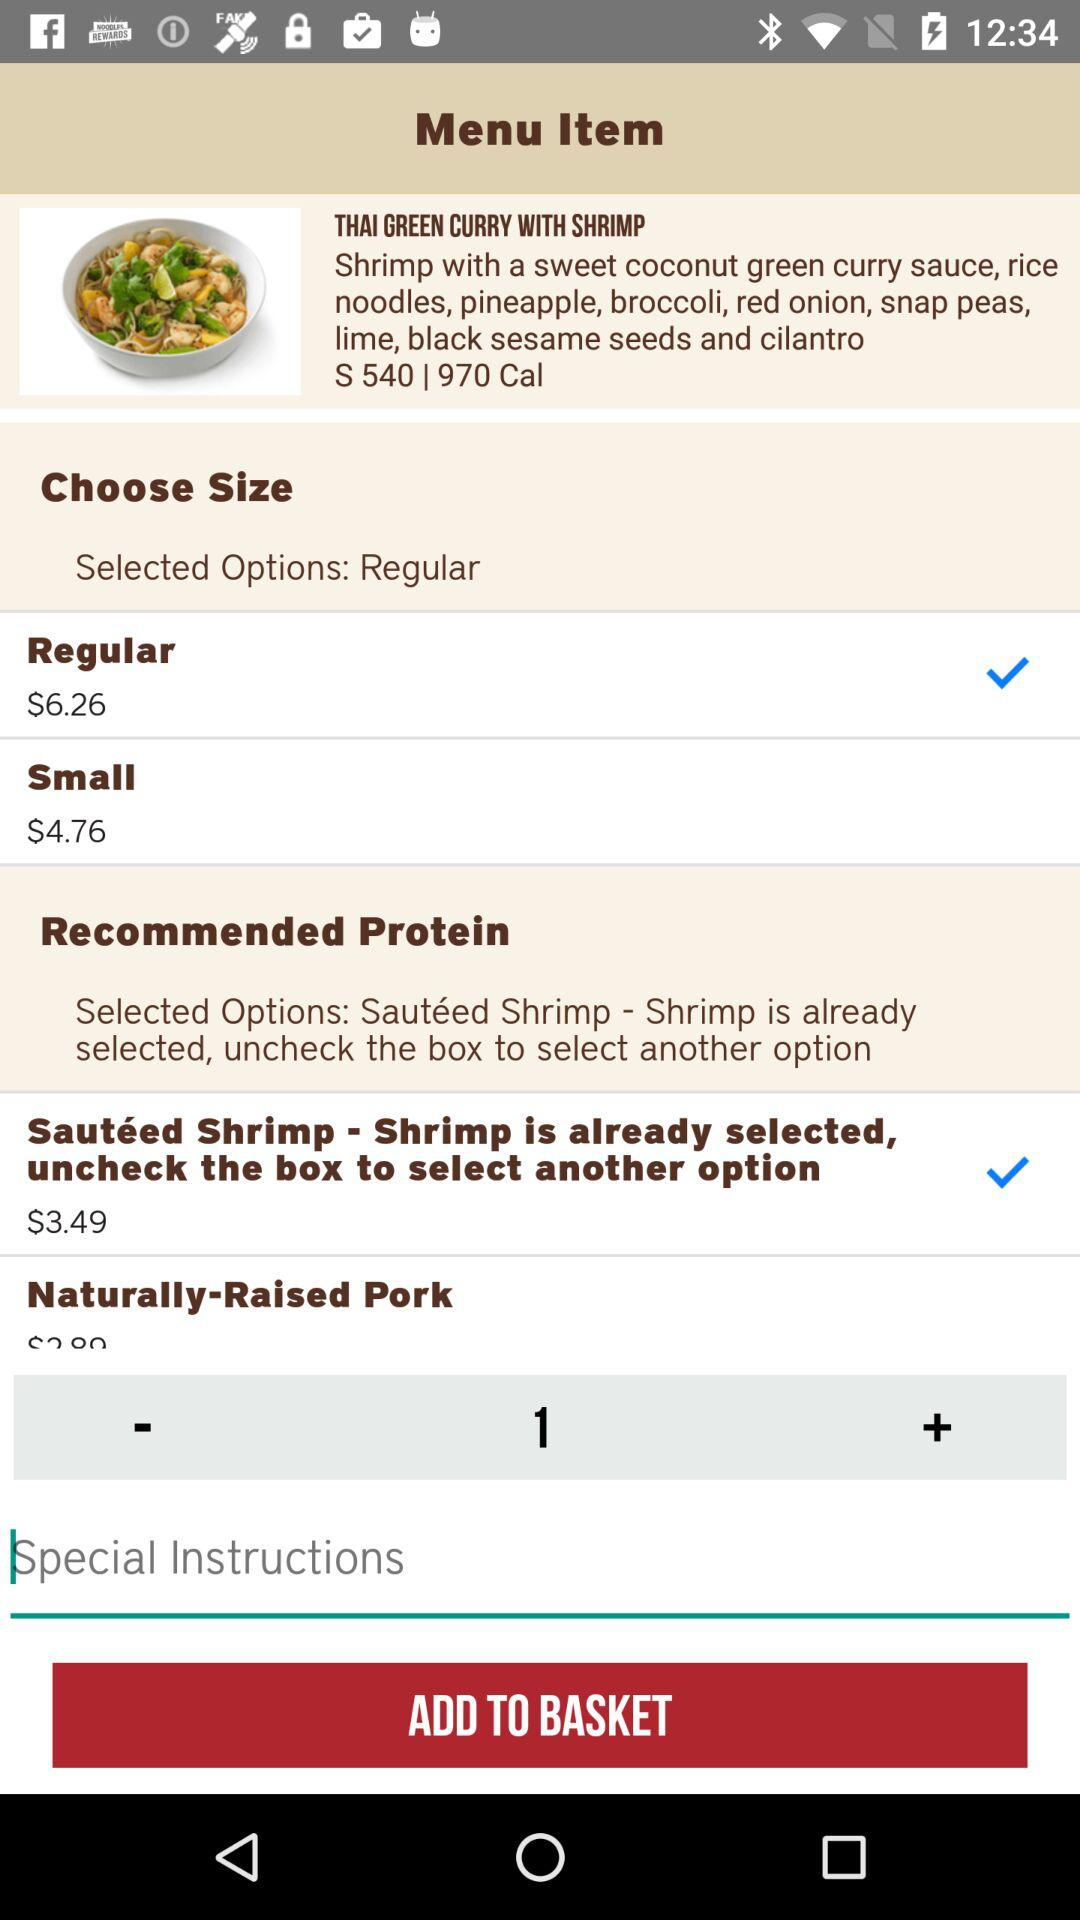How many calories are in the dish? There are 970 calories in the dish. 